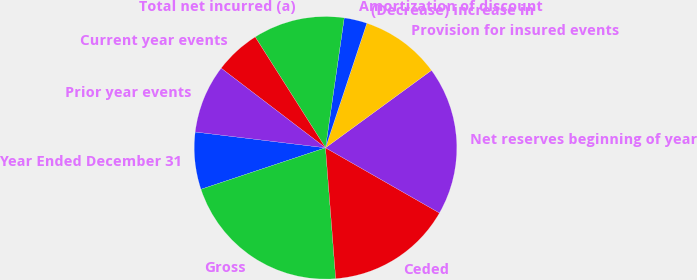<chart> <loc_0><loc_0><loc_500><loc_500><pie_chart><fcel>Year Ended December 31<fcel>Gross<fcel>Ceded<fcel>Net reserves beginning of year<fcel>Provision for insured events<fcel>(Decrease) increase in<fcel>Amortization of discount<fcel>Total net incurred (a)<fcel>Current year events<fcel>Prior year events<nl><fcel>7.04%<fcel>21.12%<fcel>15.49%<fcel>18.31%<fcel>9.86%<fcel>0.0%<fcel>2.82%<fcel>11.27%<fcel>5.63%<fcel>8.45%<nl></chart> 